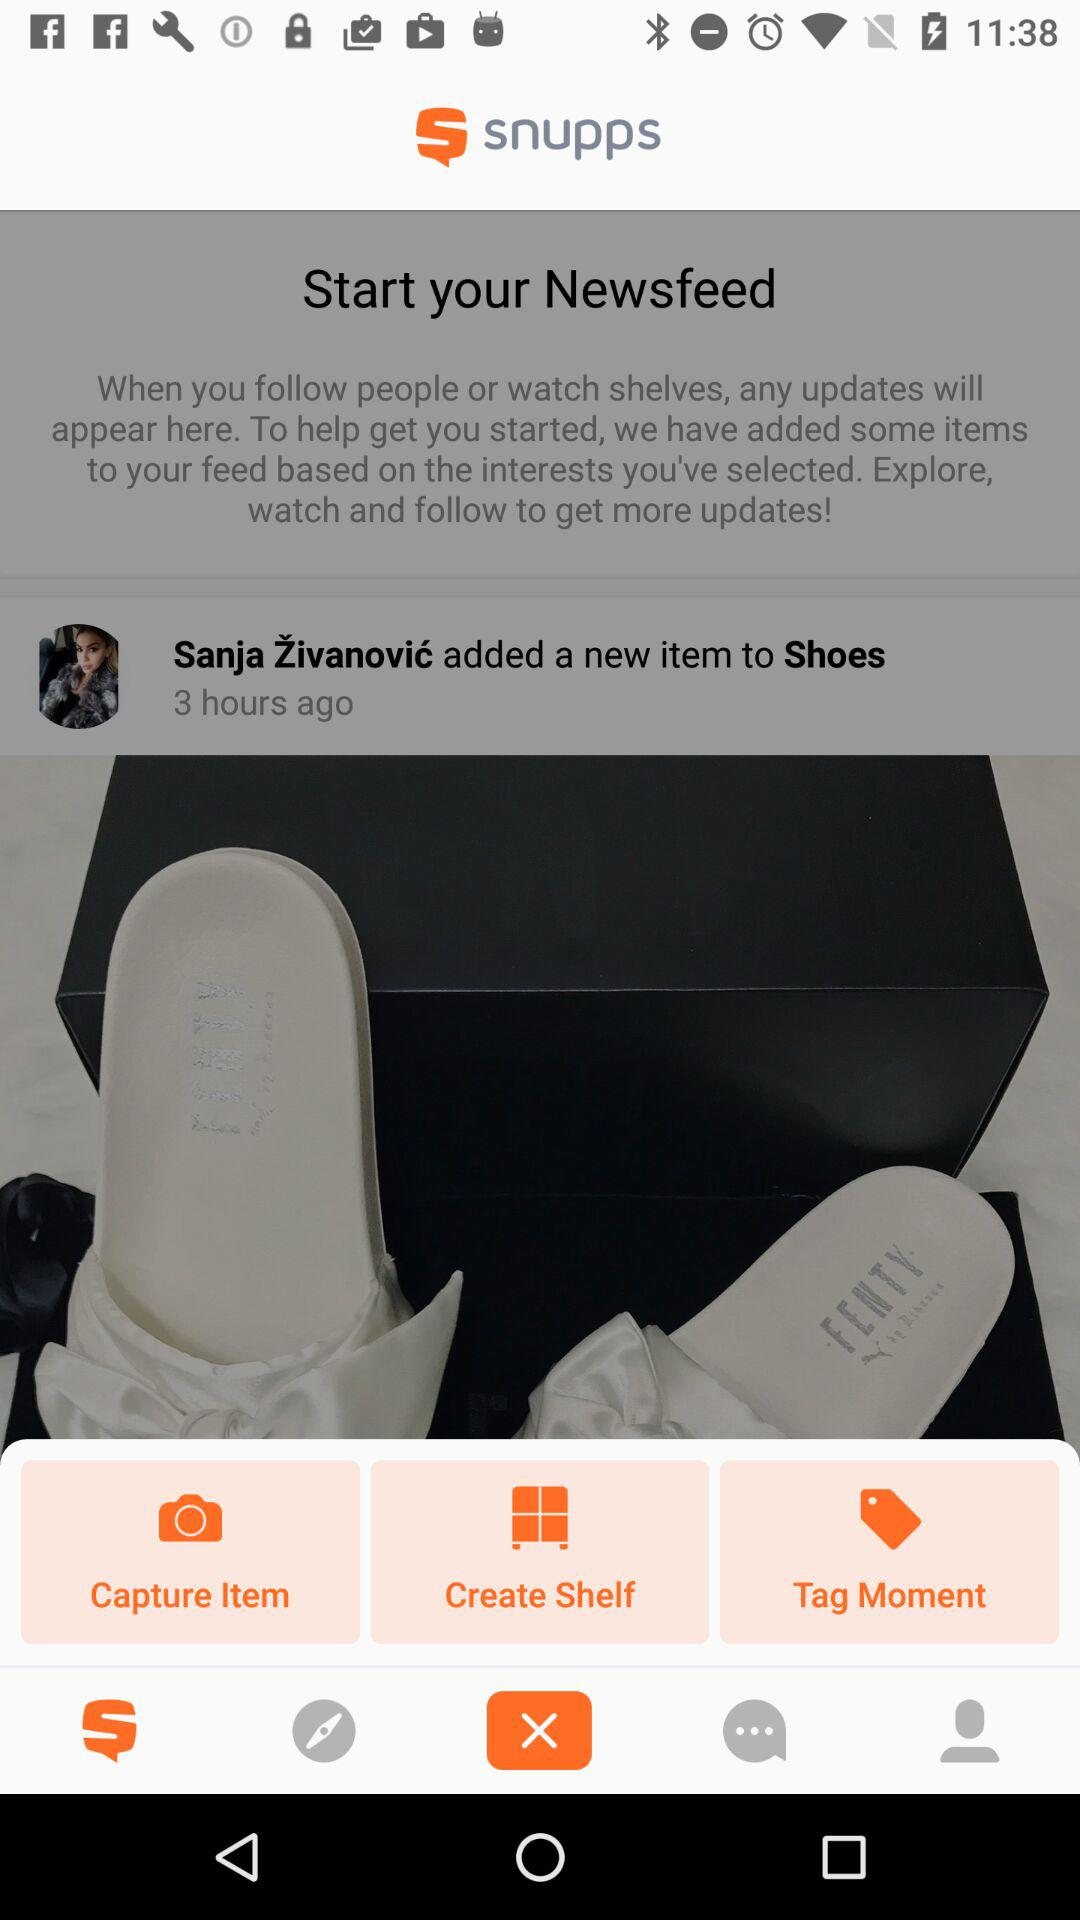Who added a new item to "Shoes"? The new item was added by Sanja Živanović. 